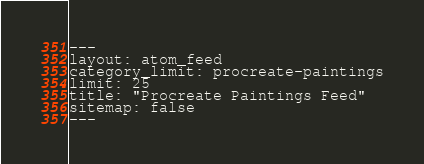Convert code to text. <code><loc_0><loc_0><loc_500><loc_500><_XML_>---
layout: atom_feed
category_limit: procreate-paintings
limit: 25
title: "Procreate Paintings Feed"
sitemap: false
---
</code> 